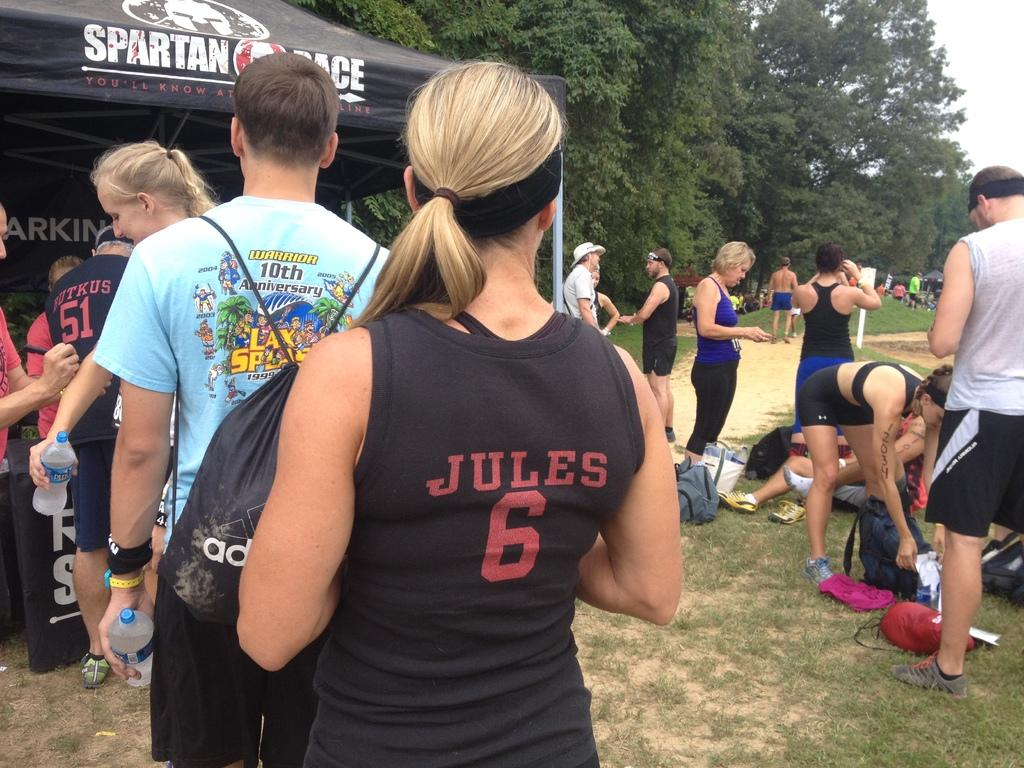What are the persons standing on in the image? The persons are standing on the ground in the image. What is the color of the ground in the image? The ground appears to be green in the image. What object is in front of the persons in the image? There is a black color object in front of the persons in the image. What can be seen in the right corner of the image? There are additional persons and trees in the right corner of the image. What type of hobbies does the doctor have in the image? There is no doctor present in the image, so it is not possible to determine their hobbies. 